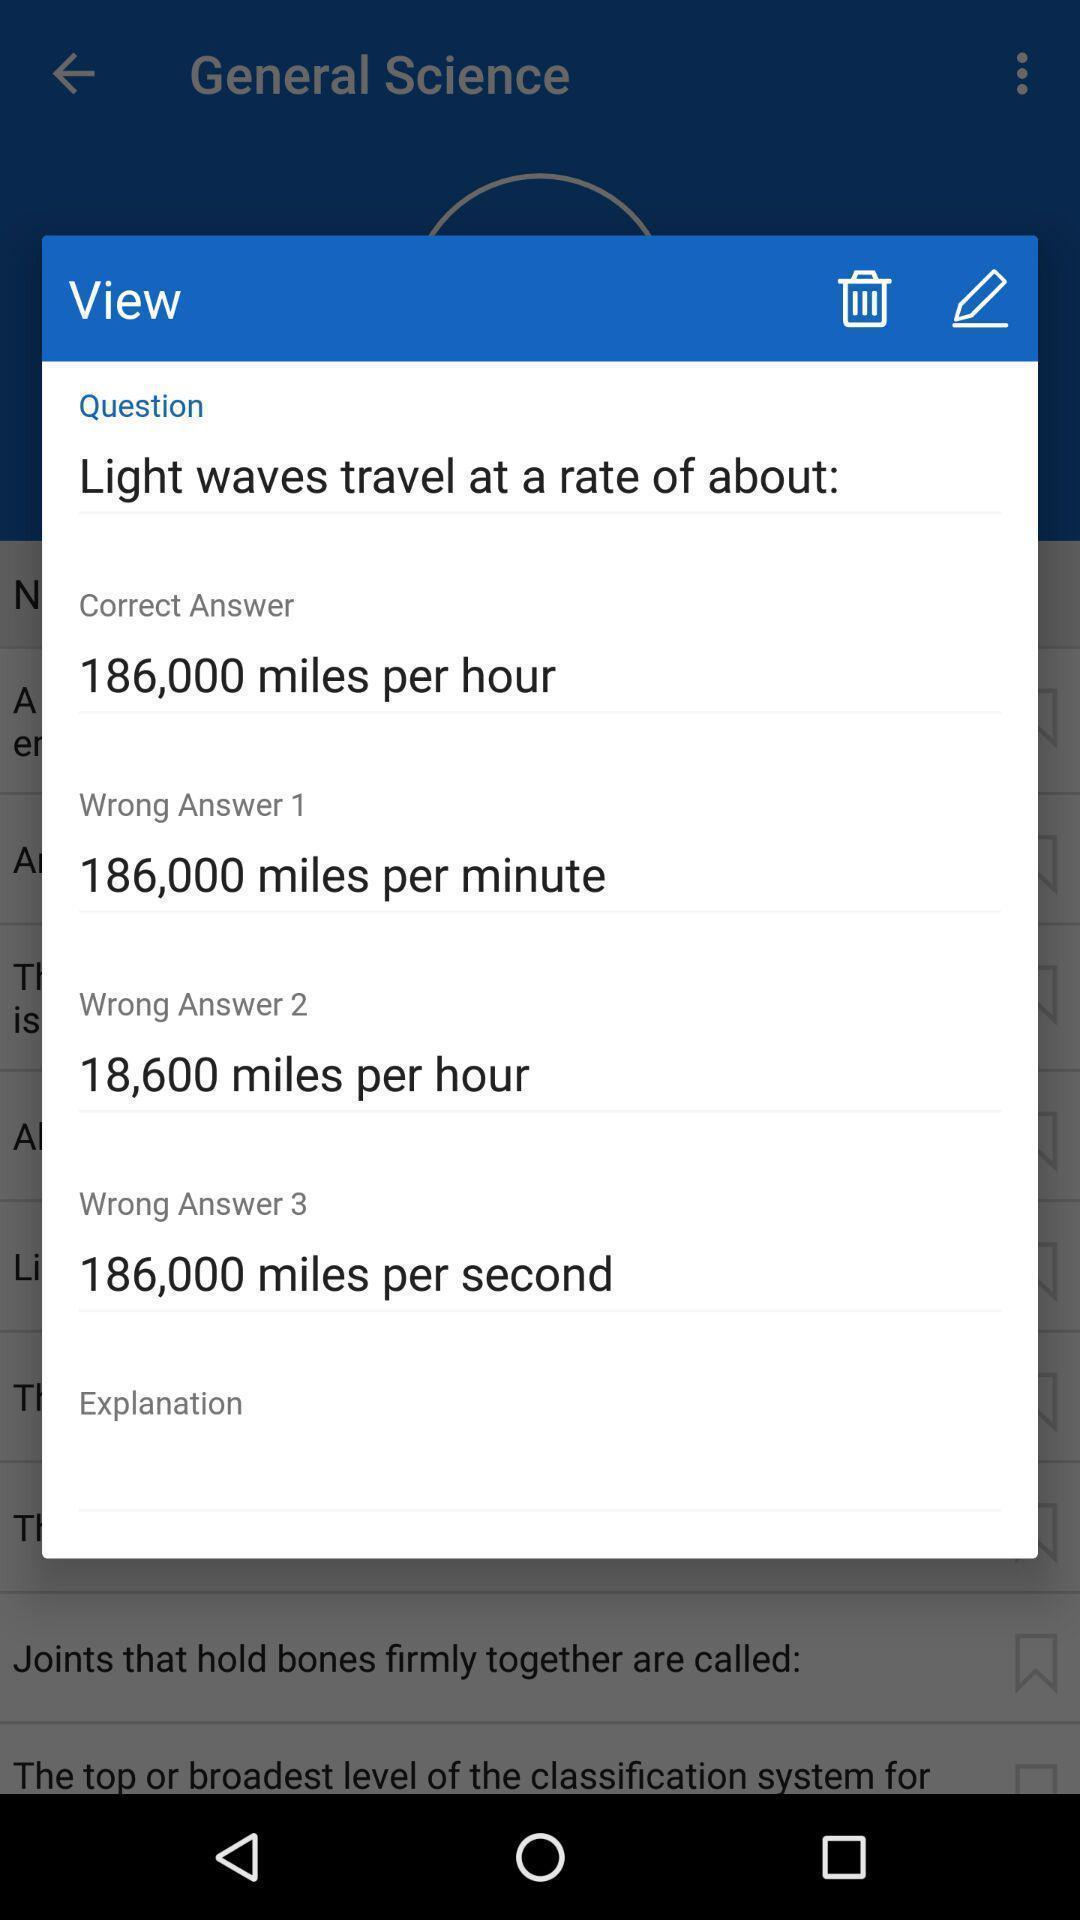What is the overall content of this screenshot? Popup view page with question and answers of learning app. 